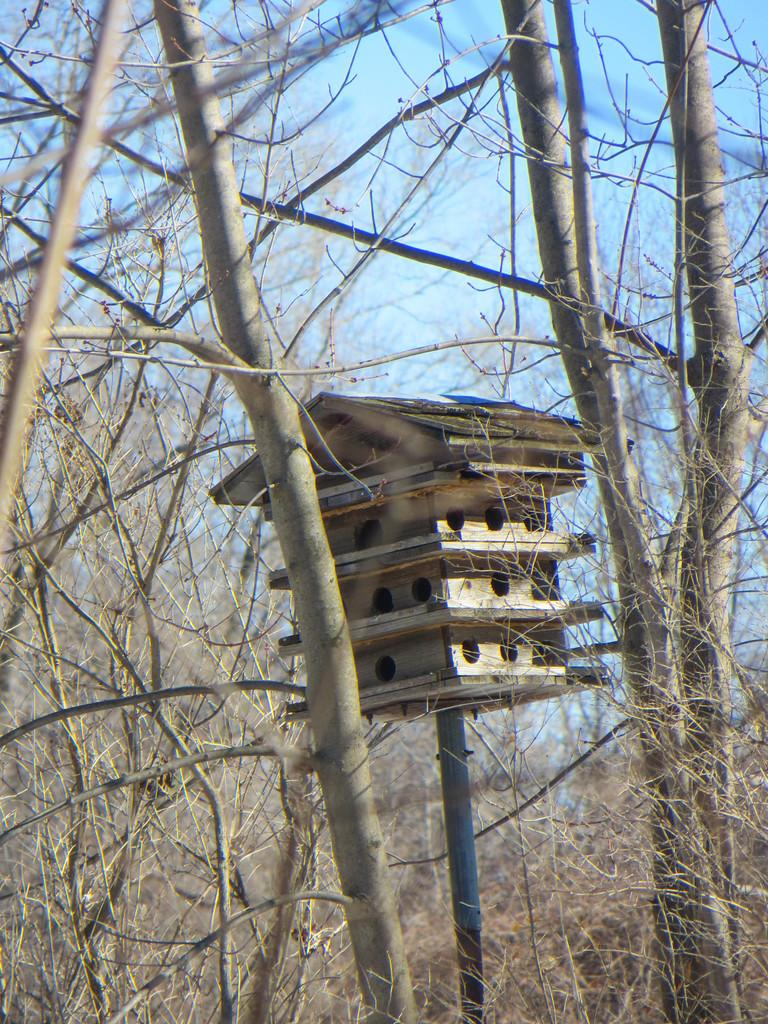What is in the foreground of the image? There are branches of a tree in the foreground of the image. What can be seen in the middle of the image? There is a bird house in the middle of the image. What is visible in the background of the image? The sky is visible in the background of the image. What type of picture is hanging on the wall in the image? There is no mention of a picture hanging on the wall in the image; the facts provided only mention branches of a tree, a bird house, and the sky. 